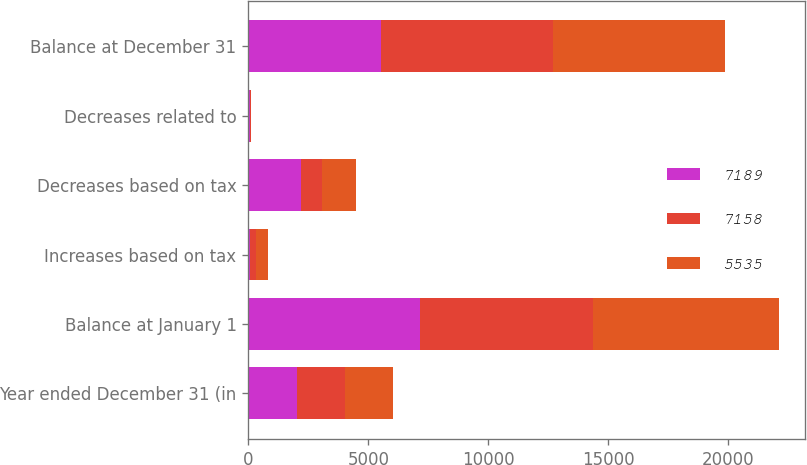<chart> <loc_0><loc_0><loc_500><loc_500><stacked_bar_chart><ecel><fcel>Year ended December 31 (in<fcel>Balance at January 1<fcel>Increases based on tax<fcel>Decreases based on tax<fcel>Decreases related to<fcel>Balance at December 31<nl><fcel>7189<fcel>2013<fcel>7158<fcel>88<fcel>2200<fcel>53<fcel>5535<nl><fcel>7158<fcel>2012<fcel>7189<fcel>234<fcel>853<fcel>50<fcel>7158<nl><fcel>5535<fcel>2011<fcel>7767<fcel>496<fcel>1433<fcel>16<fcel>7189<nl></chart> 